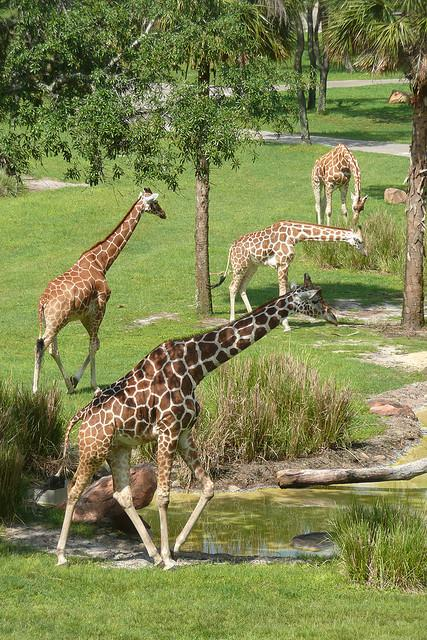What does the animal in the foreground have?

Choices:
A) wings
B) gills
C) spots
D) quills spots 